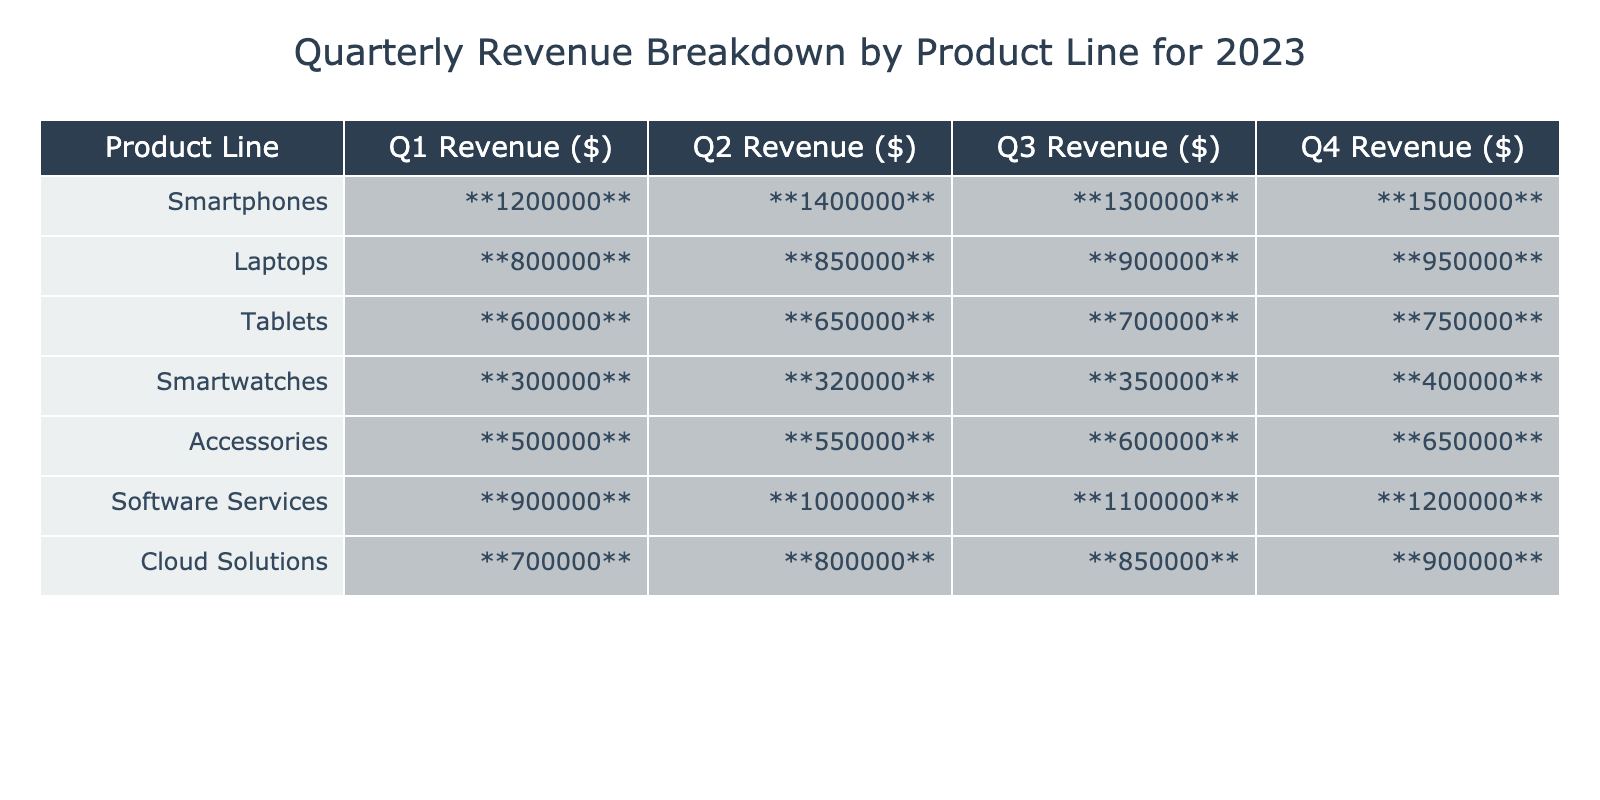What is the total revenue for Smartphones in Q1? The revenue for Smartphones in Q1 is listed as 1,200,000. Therefore, the total revenue is simply this value.
Answer: 1,200,000 What was the revenue for Accessories in Q2? The revenue for Accessories in Q2 is shown as 550,000. This is directly stated in the table.
Answer: 550,000 Which product line had the highest revenue in Q4? In Q4, the revenue values are 1,500,000 for Smartphones, 950,000 for Laptops, 750,000 for Tablets, 400,000 for Smartwatches, 650,000 for Accessories, and 1,200,000 for Software Services. Comparing these values, Smartphones had the highest revenue at 1,500,000.
Answer: Smartphones What is the average revenue for Tablets across all quarters? To find the average revenue for Tablets, first sum the revenues for all quarters: 600,000 + 650,000 + 700,000 + 750,000 = 2,700,000. Then, divide this total by the number of quarters (4): 2,700,000 / 4 = 675,000.
Answer: 675,000 Did Software Services generate more revenue than Laptops in Q3? In Q3, Software Services had a revenue of 1,100,000, while Laptops had a revenue of 900,000. Since 1,100,000 is greater than 900,000, the answer is yes.
Answer: Yes What is the total revenue for all product lines in Q2? To find the total revenue for all product lines in Q2, we sum the values: 1,400,000 (Smartphones) + 850,000 (Laptops) + 650,000 (Tablets) + 320,000 (Smartwatches) + 550,000 (Accessories) + 1,000,000 (Software Services) + 800,000 (Cloud Solutions) = 5,570,000.
Answer: 5,570,000 By what percentage did the revenue for Cloud Solutions increase from Q1 to Q4? The revenue for Cloud Solutions in Q1 is 700,000 and in Q4 it is 900,000. To find the percentage increase, subtract the Q1 revenue from Q4 revenue: 900,000 - 700,000 = 200,000. Then divide by the Q1 revenue and multiply by 100: (200,000 / 700,000) * 100 ≈ 28.57%.
Answer: Approximately 28.57% Which product line shows the smallest increase in revenue from Q1 to Q2? Comparing the increases from Q1 to Q2: Smartphones (200,000), Laptops (50,000), Tablets (50,000), Smartwatches (20,000), Accessories (50,000), Software Services (100,000), and Cloud Solutions (100,000). The smallest increase is 20,000 for Smartwatches.
Answer: Smartwatches 